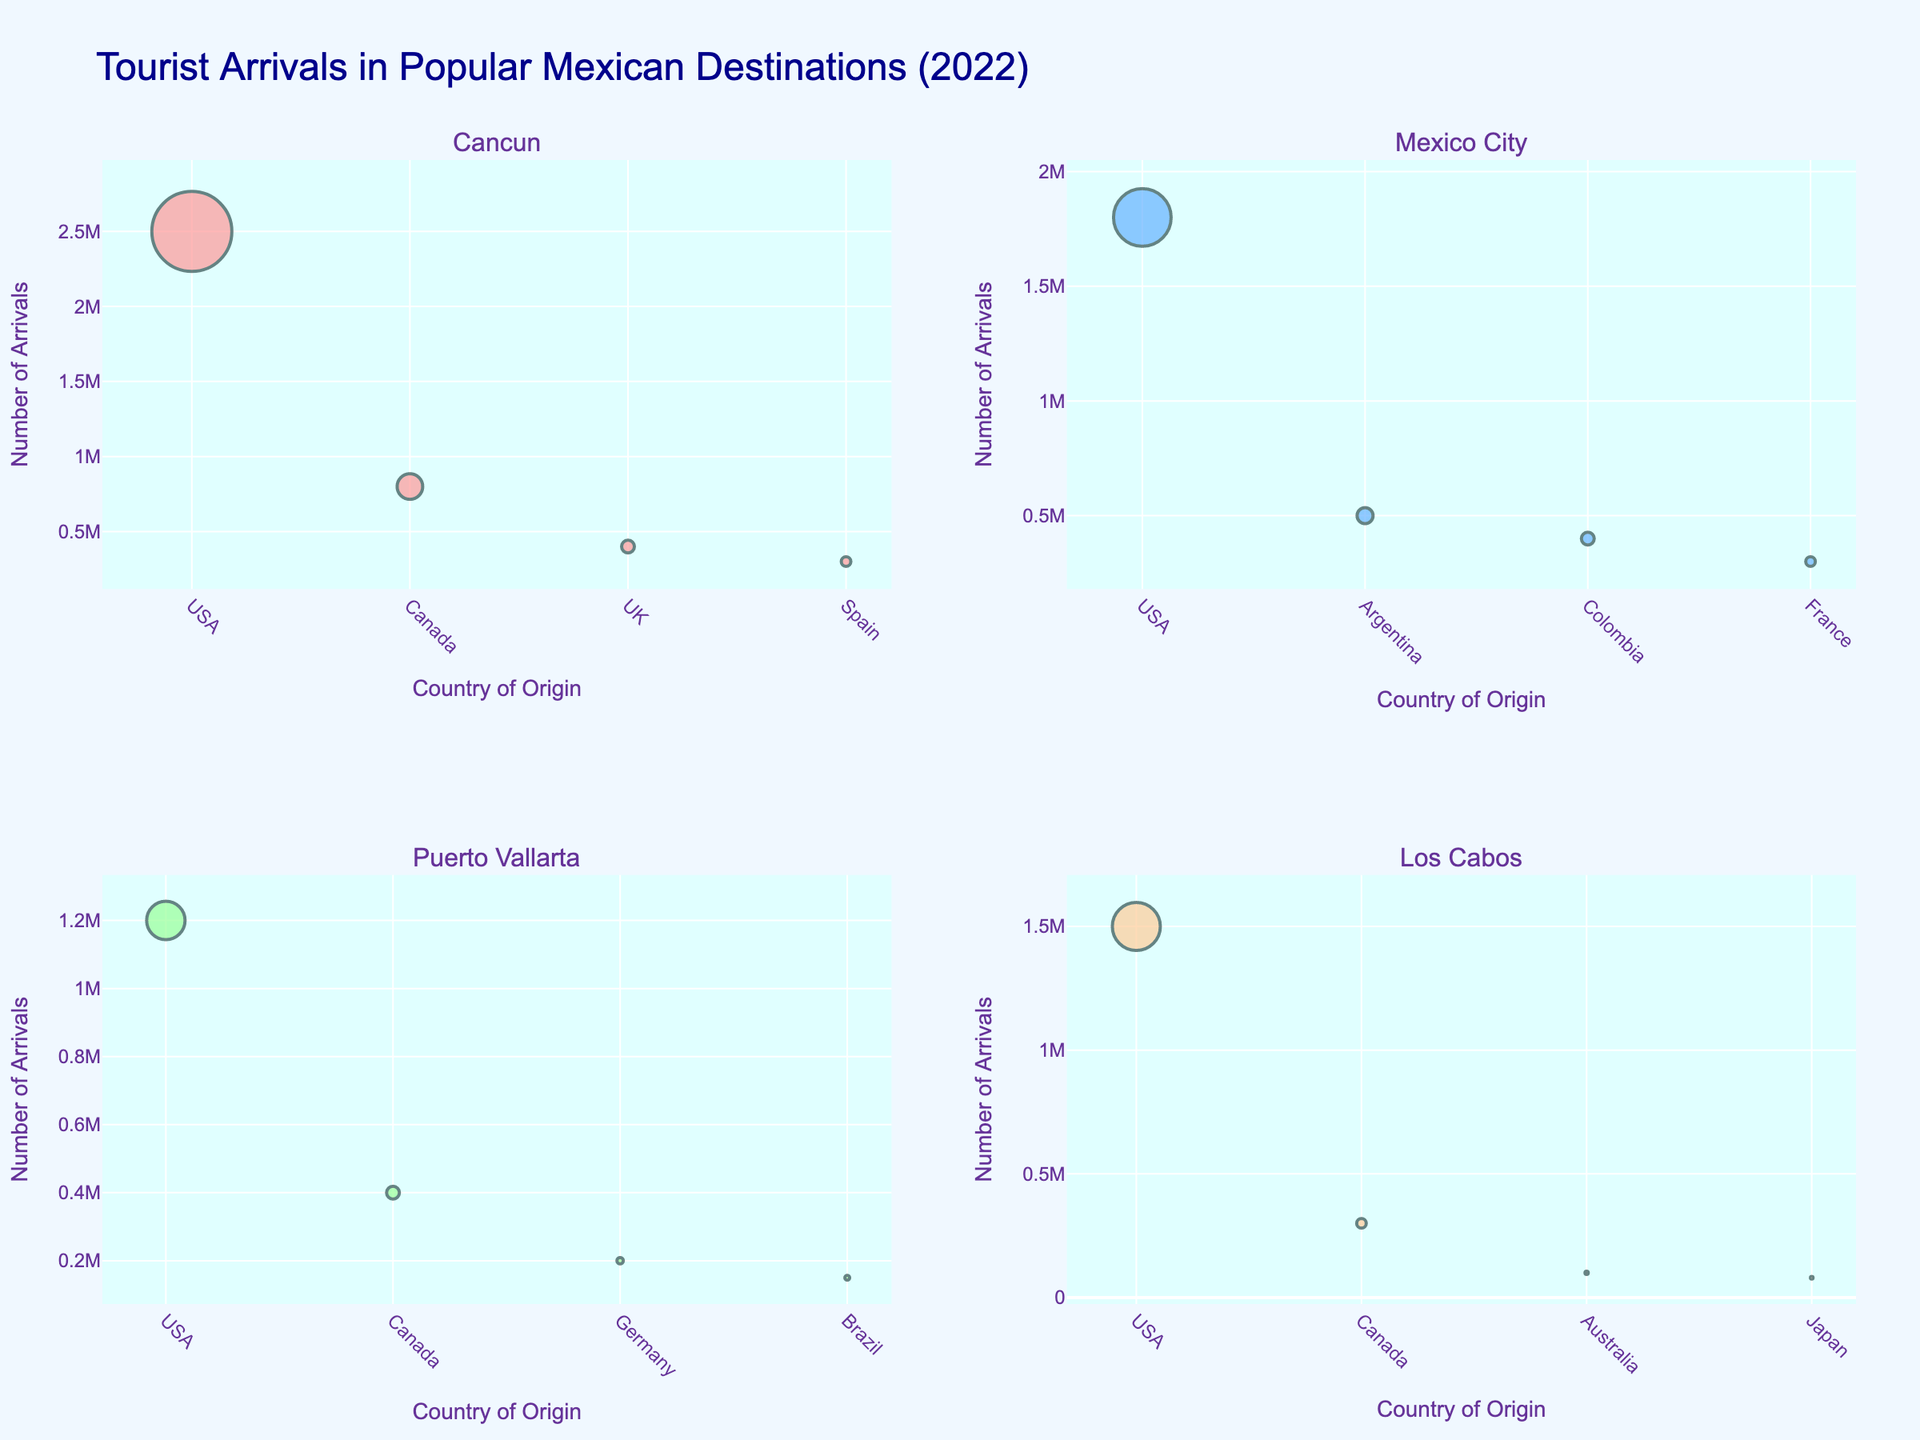What's the most popular destination for tourists from the USA? Look at the scatter plots and identify the destination with the largest marker for tourists from the USA. The size of the marker indicates the number of arrivals.
Answer: Cancun What's the total number of US tourists across all destinations? Sum the number of US arrivals for each destination: Cancun (2,500,000) + Mexico City (1,800,000) + Puerto Vallarta (1,200,000) + Los Cabos (1,500,000).
Answer: 7,000,000 Which country of origin contributes the least to Los Cabos' tourist arrivals? Identify the marker with the smallest size for Los Cabos. Review the data for Los Cabos and see which country has the lowest number of tourists.
Answer: Japan How does the number of arrivals from Canada to Puerto Vallarta compare to Mexico City? Look at the scatter plots and compare the sizes of the markers for Canadian arrivals in Puerto Vallarta (400,000) and Mexico City (none shown, so 0).
Answer: Higher in Puerto Vallarta Which destination has a higher number of tourists from France? Cancun or Mexico City? Compare the markers for French tourists in both Cancun and Mexico City. The marker size will indicate this.
Answer: Mexico City What are the three countries that send the most tourists to Cancun? Identify the three largest markers for Cancun, which represent the countries with the highest arrivals.
Answer: USA, Canada, UK What's the difference in tourist arrivals from Canada to Cancun and Los Cabos? Subtract the number of Canadian arrivals in Los Cabos (300,000) from those in Cancun (800,000).
Answer: 500,000 What is the average number of tourist arrivals for Brazil across all destinations shown? Sum the arrivals of Brazilian tourists in all applicable destinations and divide by the number of destinations (Puerto Vallarta: 150,000). Since only Puerto Vallarta is listed, the average is 150,000.
Answer: 150,000 Which destination has the smallest combined number of tourist arrivals from Japan and Australia? Identify the total arrivals for Japan and Australia in each destination and find the smallest sum.
Answer: Los Cabos (Japan: 80,000, Australia: 100,000) What's the most popular destination for tourists from Argentina? Look at the marker size for Argentinian arrivals in the scatter plots to see which destination is the largest.
Answer: Mexico City 